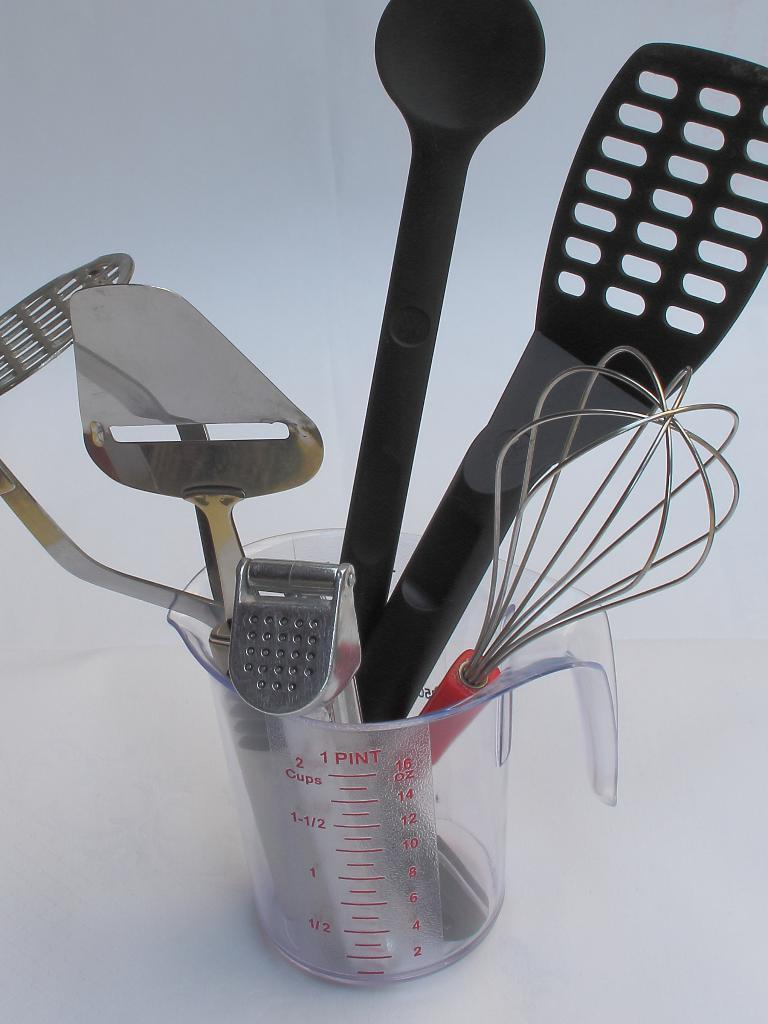What object is located in the center of the image? There is a mug in the center of the image. What is inside the mug? The mug contains spatulas and a tuner. Can you describe the contents of the mug in more detail? The mug contains spatulas and a tuner, which are likely used for cooking and tuning musical instruments, respectively. How many boys are visible in the image? There are no boys present in the image; it features a mug with spatulas and a tuner. What type of stem is growing out of the mug in the image? There is no stem growing out of the mug in the image; it contains spatulas and a tuner. 